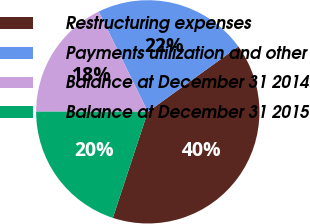Convert chart to OTSL. <chart><loc_0><loc_0><loc_500><loc_500><pie_chart><fcel>Restructuring expenses<fcel>Payments utilization and other<fcel>Balance at December 31 2014<fcel>Balance at December 31 2015<nl><fcel>40.02%<fcel>22.29%<fcel>17.73%<fcel>19.96%<nl></chart> 